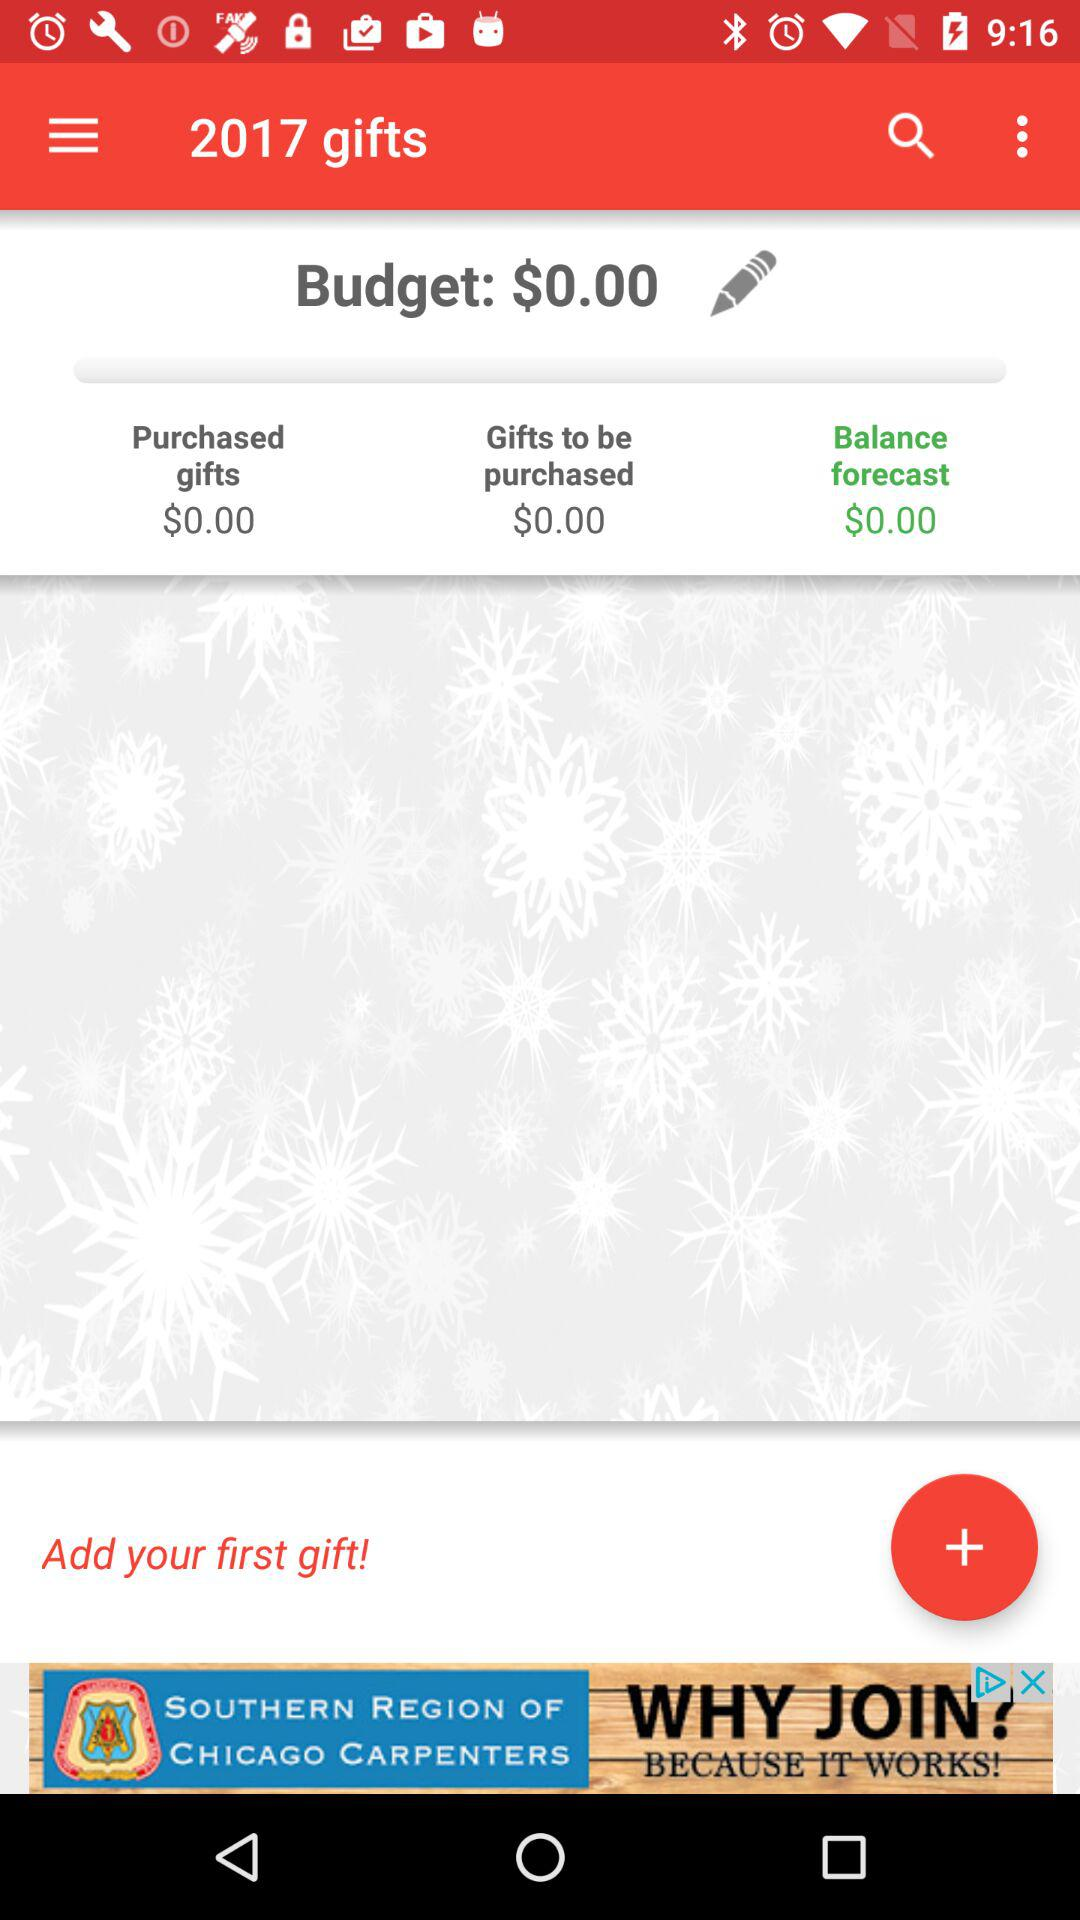What do the gifts to be purchased cost? The cost is $0. 